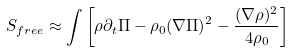<formula> <loc_0><loc_0><loc_500><loc_500>S _ { f r e e } \approx \int \left [ \rho \partial _ { t } \Pi - \rho _ { 0 } ( \nabla \Pi ) ^ { 2 } - \frac { ( \nabla \rho ) ^ { 2 } } { 4 \rho _ { 0 } } \right ]</formula> 